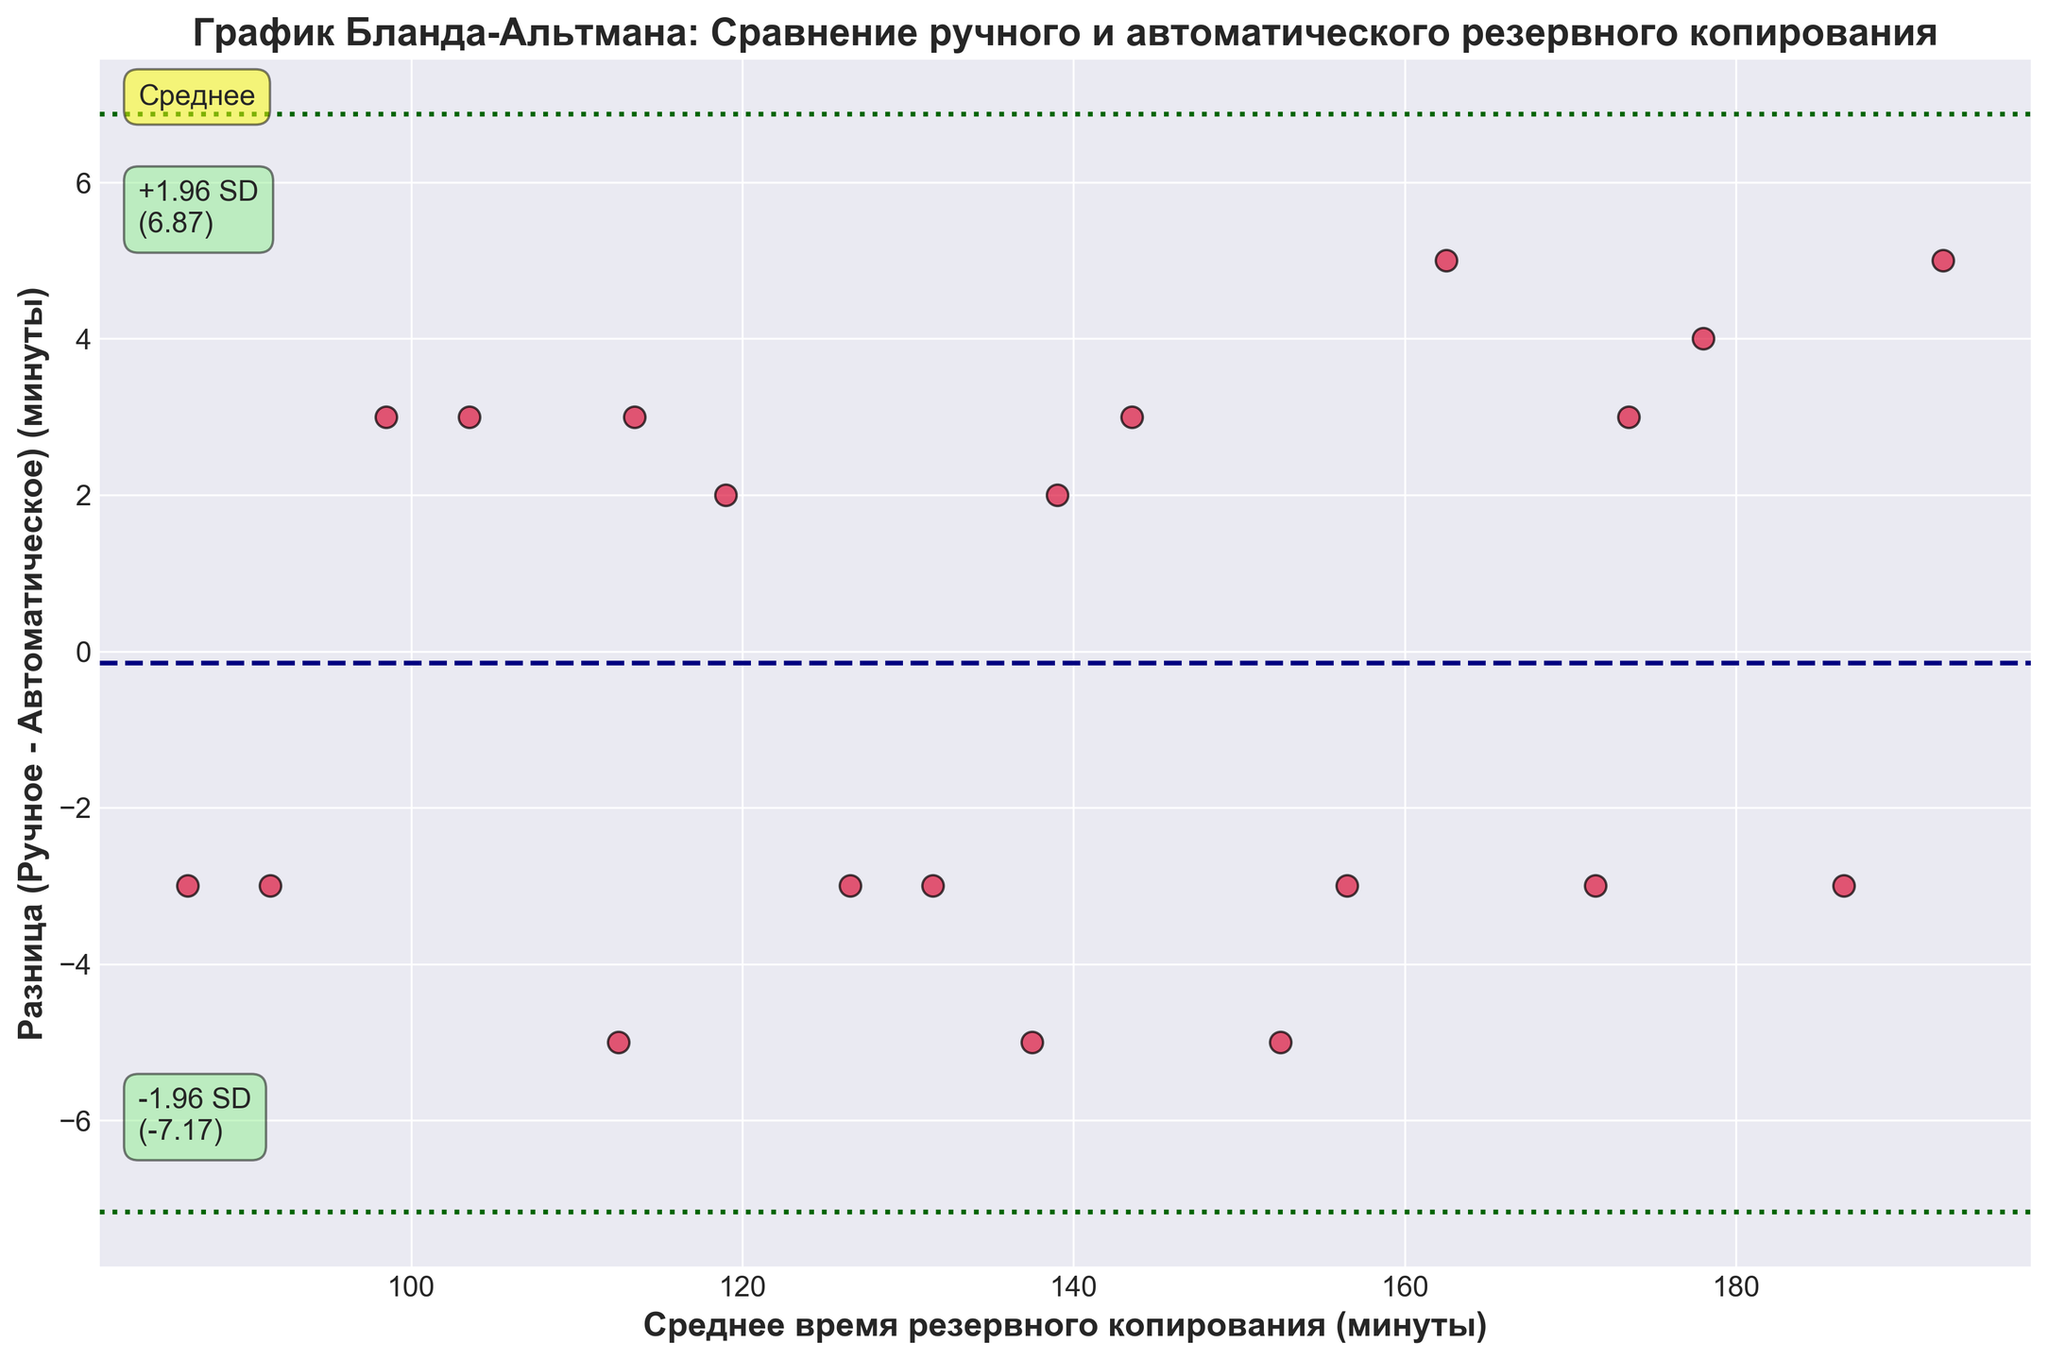What's the title of the plot? The title is located at the top of the plot, usually providing a summary of what the plot represents. In this case, it summarizes the comparison of manual and automated backup processes.
Answer: График Бланда-Альтмана: Сравнение ручного и автоматического резервного копирования What do the X and Y axes represent? The X axis represents the average time of the manual and automated processes, while the Y axis represents the difference between the manual and automated processes (manual minus automated). These details are found in the axis labels.
Answer: Среднее время резервного копирования (минуты), Разница (Ручное - Автоматическое) (минуты) What is the mean difference between manual and automated backup times? The mean difference is represented by the horizontal navy dashed line labeled "Среднее" on the plot. This line marks the central tendency of the differences.
Answer: Среднее (mean) difference = 0 (assuming equal load on both types) How many data points are there in the plot? Data points are represented by the red scatter points with black edges on the plot. By counting these points, we can determine the total number of data pairs.
Answer: 20 What do the dashed green lines on the plot represent? The dashed green lines indicate the limits of agreement, which are calculated as the mean difference ± 1.96 times the standard deviation. These lines show where most data points are likely to fall if the differences are normally distributed.
Answer: Limits of agreement What is the value of the upper limit of agreement? The upper limit of agreement is marked by the upper dashed green line. This value is calculated as the mean difference plus 1.96 times the standard deviation and is labeled right next to the upper line.
Answer: Approximately 6.92 What is the value of the lower limit of agreement? The lower limit of agreement is marked by the lower dashed green line. This line is representative of the mean difference minus 1.96 times the standard deviation and is labeled accordingly.
Answer: Approximately -6.92 Is there any visible trend or pattern in the differences over the range of average backup times? By observing the scatter plot, one can infer whether the differences between manual and automated backup times stay consistent or vary significantly over the range of average times. Notice any clustering or consistent direction of points.
Answer: No clear trend Which backup method tends to be faster on average, manual or automated? This can be inferred by examining whether the differences (Manual - Automated) are predominantly positive or negative. If most points are above the zero line, manual backups tend to take longer. If below, automated backups do.
Answer: Automated tends to be faster Are there any outliers in the data? Outliers are points that fall far outside the expected range, near the upper or lower limits of agreement, or even beyond. By locating points that are distanced significantly from the rest, these outliers can be identified.
Answer: No significant outliers 